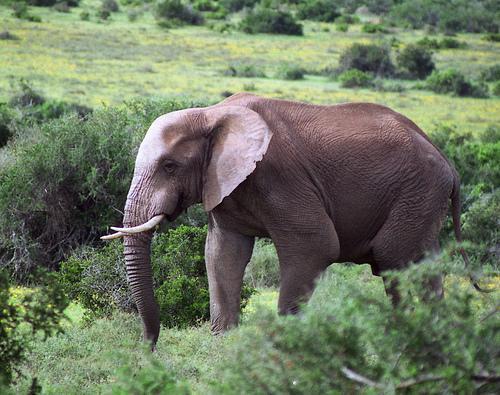How many elephant ears are shown?
Give a very brief answer. 1. How many tusks are visible?
Give a very brief answer. 2. 